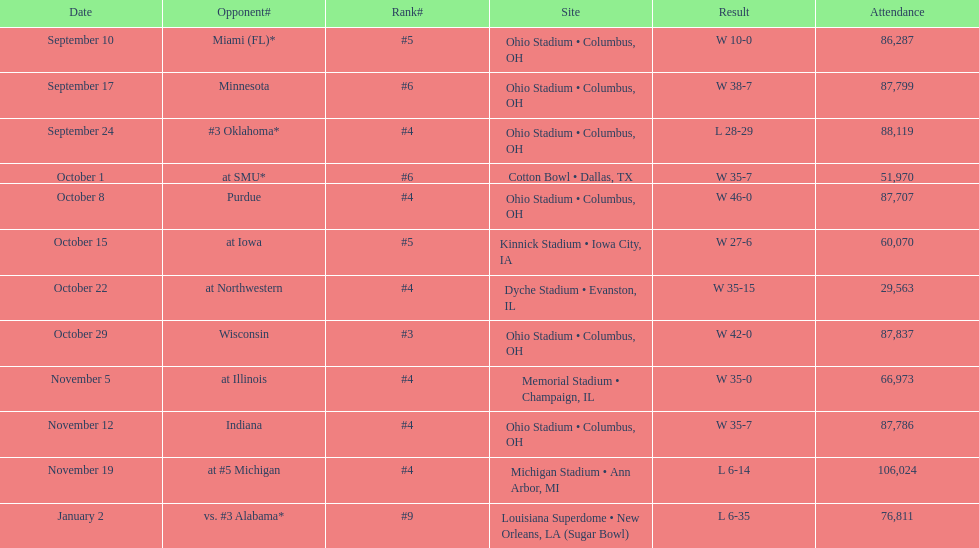What is the variance between the total of triumphs and the total of failures? 6. 